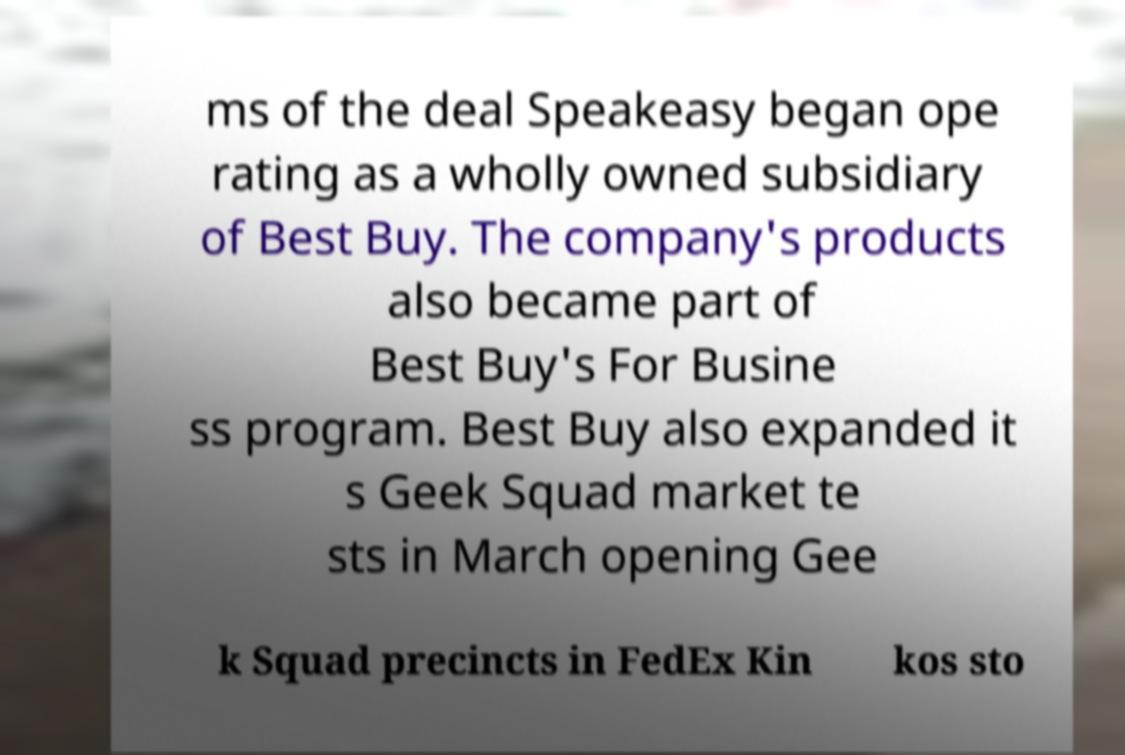What messages or text are displayed in this image? I need them in a readable, typed format. ms of the deal Speakeasy began ope rating as a wholly owned subsidiary of Best Buy. The company's products also became part of Best Buy's For Busine ss program. Best Buy also expanded it s Geek Squad market te sts in March opening Gee k Squad precincts in FedEx Kin kos sto 